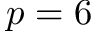<formula> <loc_0><loc_0><loc_500><loc_500>p = 6</formula> 